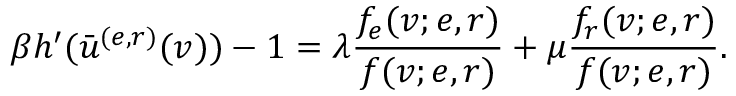Convert formula to latex. <formula><loc_0><loc_0><loc_500><loc_500>\beta h ^ { \prime } ( \bar { u } ^ { ( e , r ) } ( v ) ) - 1 = \lambda \frac { f _ { e } ( v ; e , r ) } { f ( v ; e , r ) } + \mu \frac { f _ { r } ( v ; e , r ) } { f ( v ; e , r ) } .</formula> 